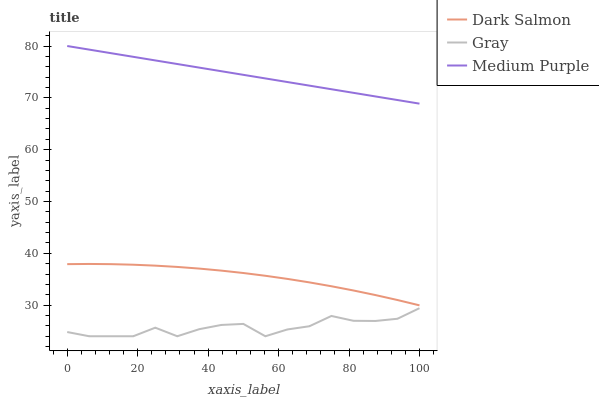Does Dark Salmon have the minimum area under the curve?
Answer yes or no. No. Does Dark Salmon have the maximum area under the curve?
Answer yes or no. No. Is Dark Salmon the smoothest?
Answer yes or no. No. Is Dark Salmon the roughest?
Answer yes or no. No. Does Dark Salmon have the lowest value?
Answer yes or no. No. Does Dark Salmon have the highest value?
Answer yes or no. No. Is Dark Salmon less than Medium Purple?
Answer yes or no. Yes. Is Medium Purple greater than Gray?
Answer yes or no. Yes. Does Dark Salmon intersect Medium Purple?
Answer yes or no. No. 